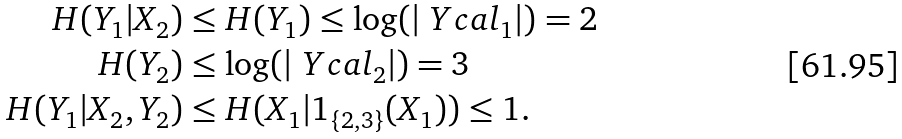<formula> <loc_0><loc_0><loc_500><loc_500>H ( Y _ { 1 } | X _ { 2 } ) & \leq H ( Y _ { 1 } ) \leq \log ( | \ Y c a l _ { 1 } | ) = 2 \\ H ( Y _ { 2 } ) & \leq \log ( | \ Y c a l _ { 2 } | ) = 3 \\ H ( Y _ { 1 } | X _ { 2 } , Y _ { 2 } ) & \leq H ( X _ { 1 } | 1 _ { \{ 2 , 3 \} } ( X _ { 1 } ) ) \leq 1 .</formula> 